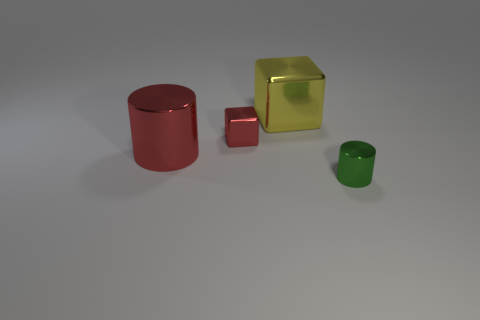There is a small object on the left side of the tiny metal object to the right of the small red metal block; what is its shape?
Keep it short and to the point. Cube. Are there any other big cylinders made of the same material as the red cylinder?
Your answer should be very brief. No. There is another metal thing that is the same shape as the large yellow metallic object; what color is it?
Provide a short and direct response. Red. Is the number of small green metallic things that are on the left side of the red metallic cube less than the number of red shiny things that are to the right of the big red metal thing?
Make the answer very short. Yes. What number of other objects are the same shape as the tiny green metal object?
Offer a terse response. 1. Is the number of big metallic cylinders behind the large red thing less than the number of brown balls?
Offer a terse response. No. There is a thing behind the tiny cube; what is its material?
Your response must be concise. Metal. How many other objects are the same size as the red metal cube?
Offer a very short reply. 1. Is the number of green rubber cubes less than the number of red things?
Offer a terse response. Yes. The green metallic thing has what shape?
Offer a terse response. Cylinder. 